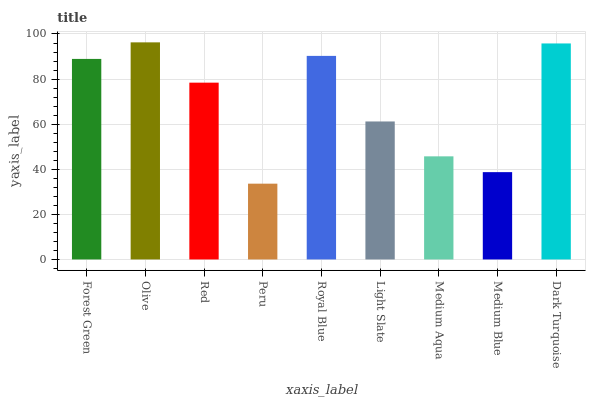Is Olive the maximum?
Answer yes or no. Yes. Is Red the minimum?
Answer yes or no. No. Is Red the maximum?
Answer yes or no. No. Is Olive greater than Red?
Answer yes or no. Yes. Is Red less than Olive?
Answer yes or no. Yes. Is Red greater than Olive?
Answer yes or no. No. Is Olive less than Red?
Answer yes or no. No. Is Red the high median?
Answer yes or no. Yes. Is Red the low median?
Answer yes or no. Yes. Is Medium Aqua the high median?
Answer yes or no. No. Is Dark Turquoise the low median?
Answer yes or no. No. 